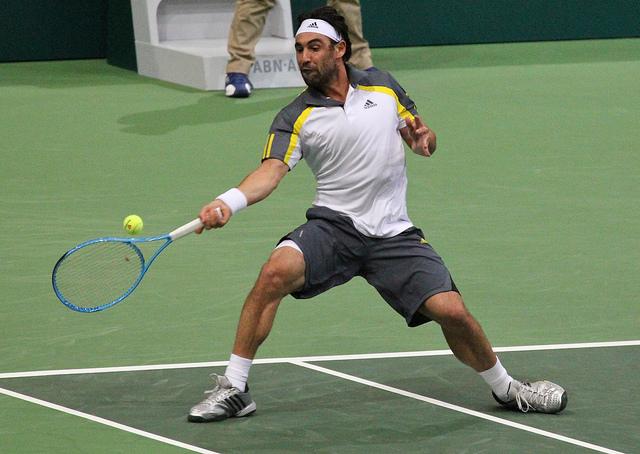Is the man focused?
Give a very brief answer. Yes. What brand of clothing is the man wearing?
Be succinct. Adidas. What is the man in back of the player doing?
Write a very short answer. Watching. 